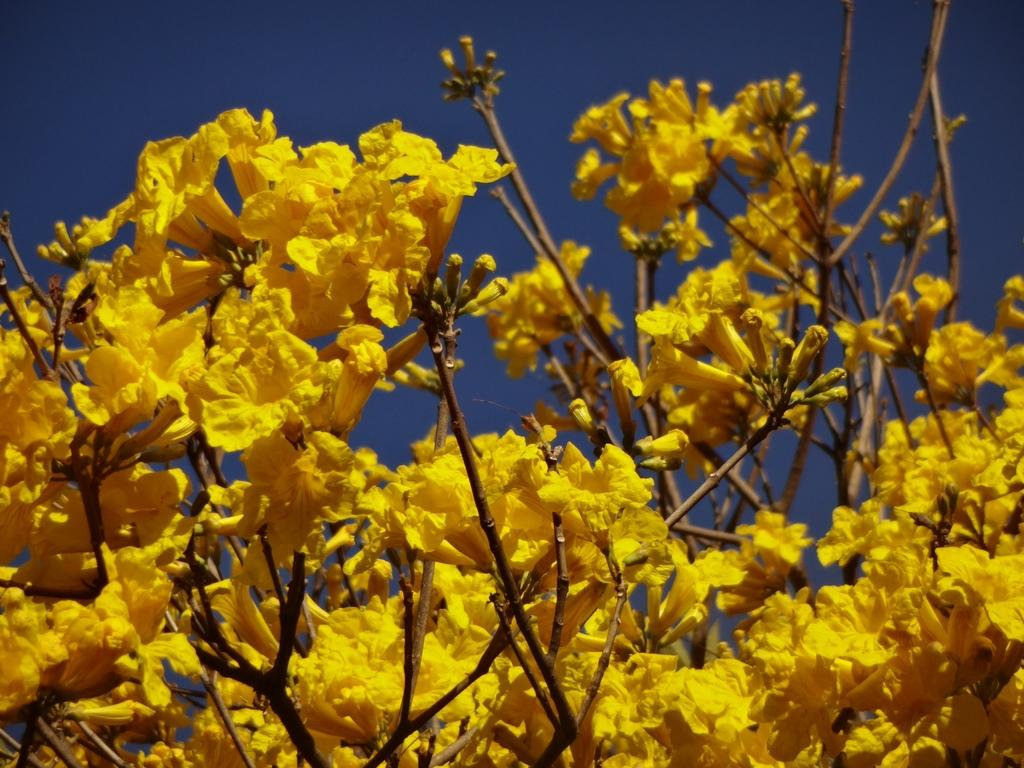What type of flowers can be seen in the image? There are yellow color flowers in the image. What part of the flowers is visible in the image? The stems of the flowers are visible in the image. What can be seen in the background of the image? The sky is visible in the background of the image. How does the earthquake affect the flowers in the image? There is no earthquake present in the image, so its effect on the flowers cannot be determined. 